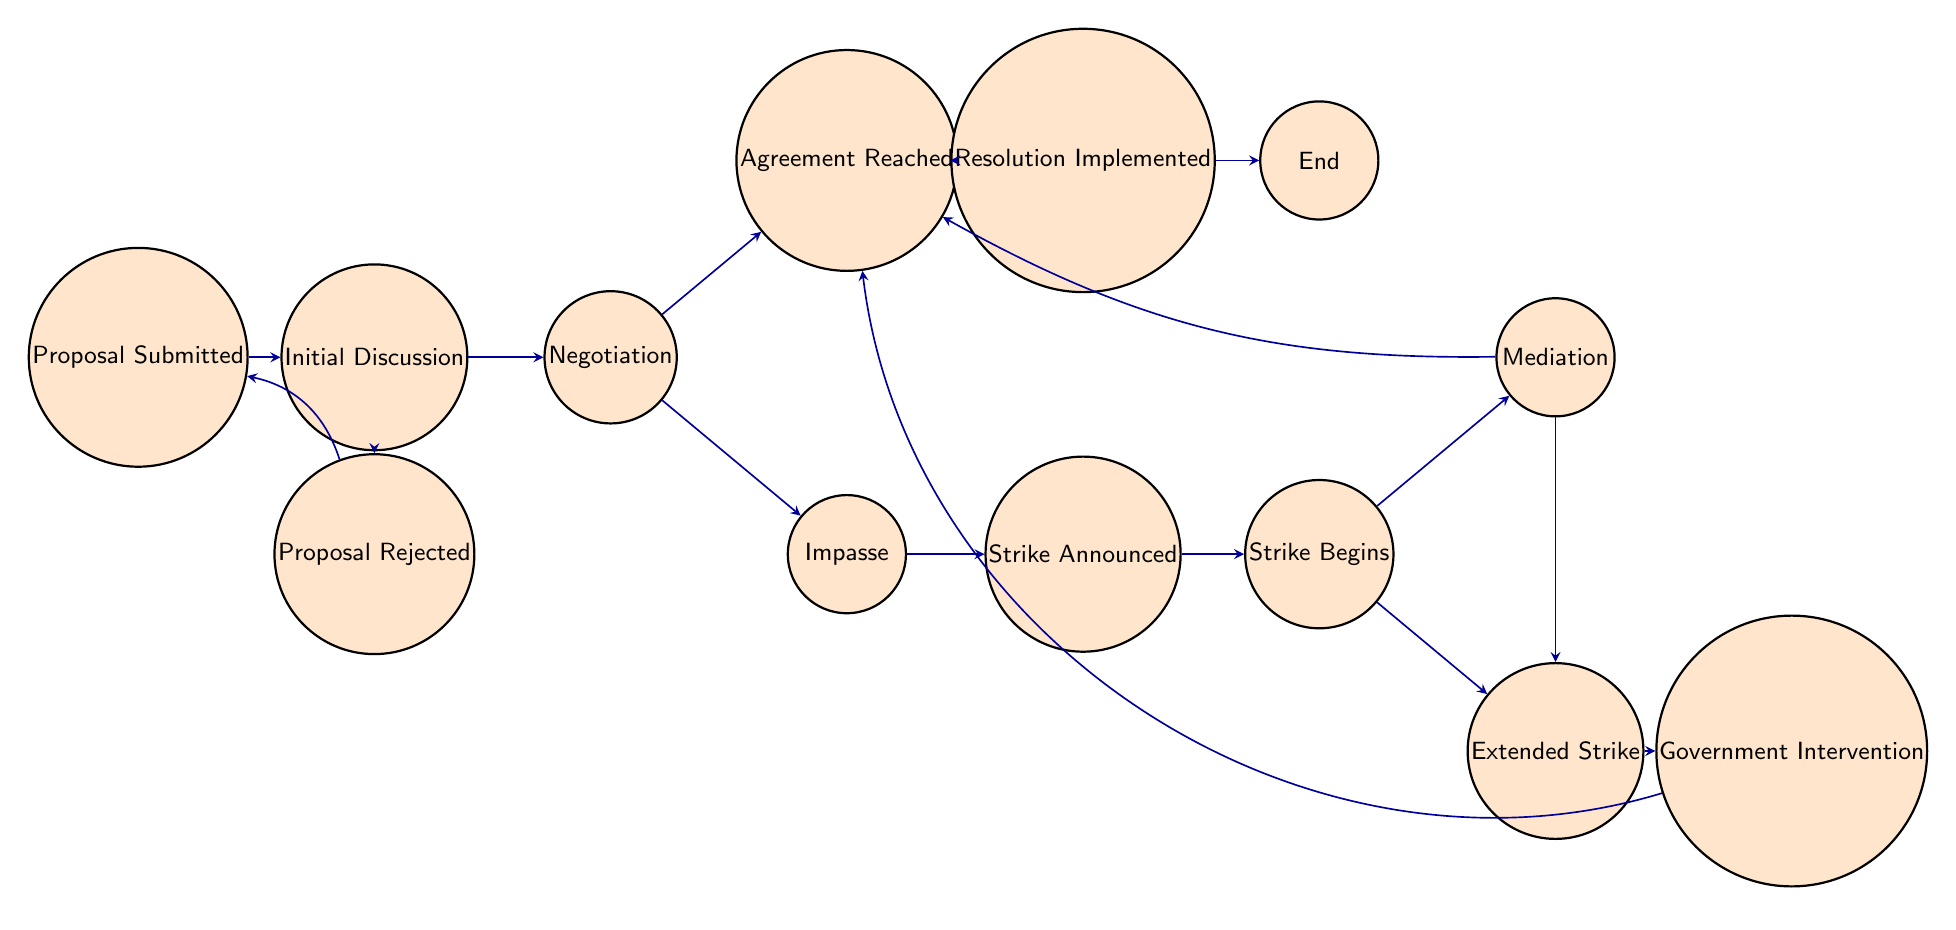What's the initial state of the process? The initial state is represented as the starting point of the diagram, which is "Proposal Submitted." This is the first state that the process starts from, according to the flow of the finite state machine.
Answer: Proposal Submitted How many states are involved in this finite state machine? By counting all the distinct states listed in the data, there are a total of 12 states represented in the diagram.
Answer: 12 What is the state reached after "Strike Announced"? After "Strike Announced," the next state in the flow is "Strike Begins." This transition follows directly from the "Strike Announced" state, indicating the progress in the strike process.
Answer: Strike Begins What happens if negotiations reach an impasse? If negotiations result in an impasse, the process transitions to "Strike Announced," indicating that the faculty union will declare a strike due to unresolved issues in negotiations.
Answer: Strike Announced What action follows an agreement being reached? Once an agreement is reached, the next step is "Resolution Implemented," which means that the agreed terms will be put into action to resume regular activities.
Answer: Resolution Implemented What leads to "Government Intervention"? "Government Intervention" occurs after an "Extended Strike," which indicates that mediation efforts have failed, prompting external governmental action to resolve the situation.
Answer: Extended Strike Which state requires a mediator to facilitate negotiations? The state that involves mediation to assist in negotiations is "Mediation." This occurs after the strike has begun and is aimed at resolving conflicts between the union and administration.
Answer: Mediation If the proposal is rejected, what is the next state? If the proposal is rejected, it leads back to the state "Proposal Submitted," indicating that the union may reassess and submit a new proposal for consideration.
Answer: Proposal Submitted How many transitions lead out of the "Negotiation" state? From the "Negotiation" state, there are two transitions leading out: one to "Agreement Reached" and another to "Impasse," indicating pathways based on the outcome of negotiations.
Answer: 2 What results from an "Extended Strike"? An "Extended Strike" results in "Government Intervention," as the strike continues and external help is sought to resolve the prolonged situation.
Answer: Government Intervention 